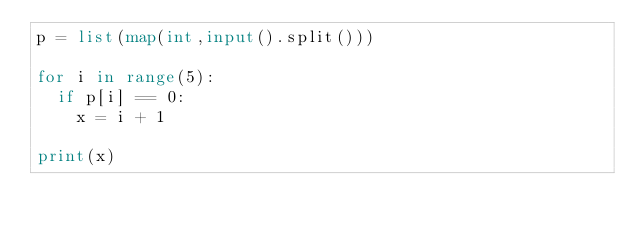Convert code to text. <code><loc_0><loc_0><loc_500><loc_500><_Python_>p = list(map(int,input().split()))

for i in range(5):
  if p[i] == 0:
    x = i + 1
    
print(x)
</code> 